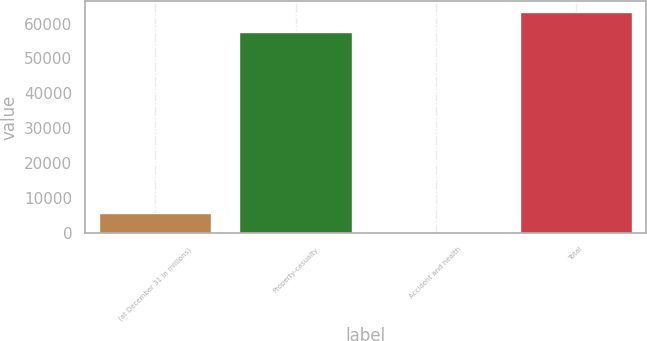<chart> <loc_0><loc_0><loc_500><loc_500><bar_chart><fcel>(at December 31 in millions)<fcel>Property-casualty<fcel>Accident and health<fcel>Total<nl><fcel>5842.9<fcel>57619<fcel>81<fcel>63380.9<nl></chart> 